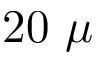<formula> <loc_0><loc_0><loc_500><loc_500>2 0 \mu</formula> 